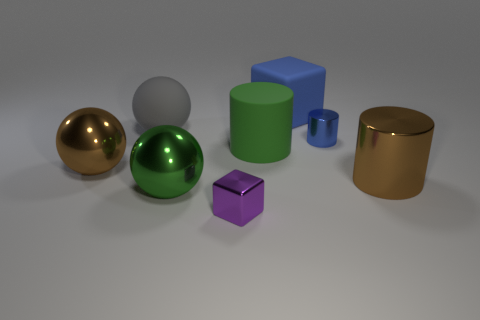There is a ball left of the large gray matte thing; is it the same color as the big shiny cylinder?
Give a very brief answer. Yes. Are there more green rubber cylinders than cubes?
Your response must be concise. No. There is a metal object that is both to the right of the large green shiny thing and to the left of the blue shiny cylinder; what size is it?
Your response must be concise. Small. The blue matte thing has what shape?
Give a very brief answer. Cube. Is there any other thing that is the same size as the green metallic sphere?
Keep it short and to the point. Yes. Is the number of balls that are in front of the rubber ball greater than the number of large purple shiny blocks?
Provide a succinct answer. Yes. There is a big brown object behind the large brown shiny thing that is on the right side of the large green thing that is on the right side of the small shiny block; what is its shape?
Ensure brevity in your answer.  Sphere. Does the rubber thing left of the metal cube have the same size as the large brown ball?
Offer a terse response. Yes. The shiny thing that is in front of the small blue cylinder and on the right side of the tiny purple cube has what shape?
Your response must be concise. Cylinder. Does the large block have the same color as the small thing that is behind the brown sphere?
Ensure brevity in your answer.  Yes. 